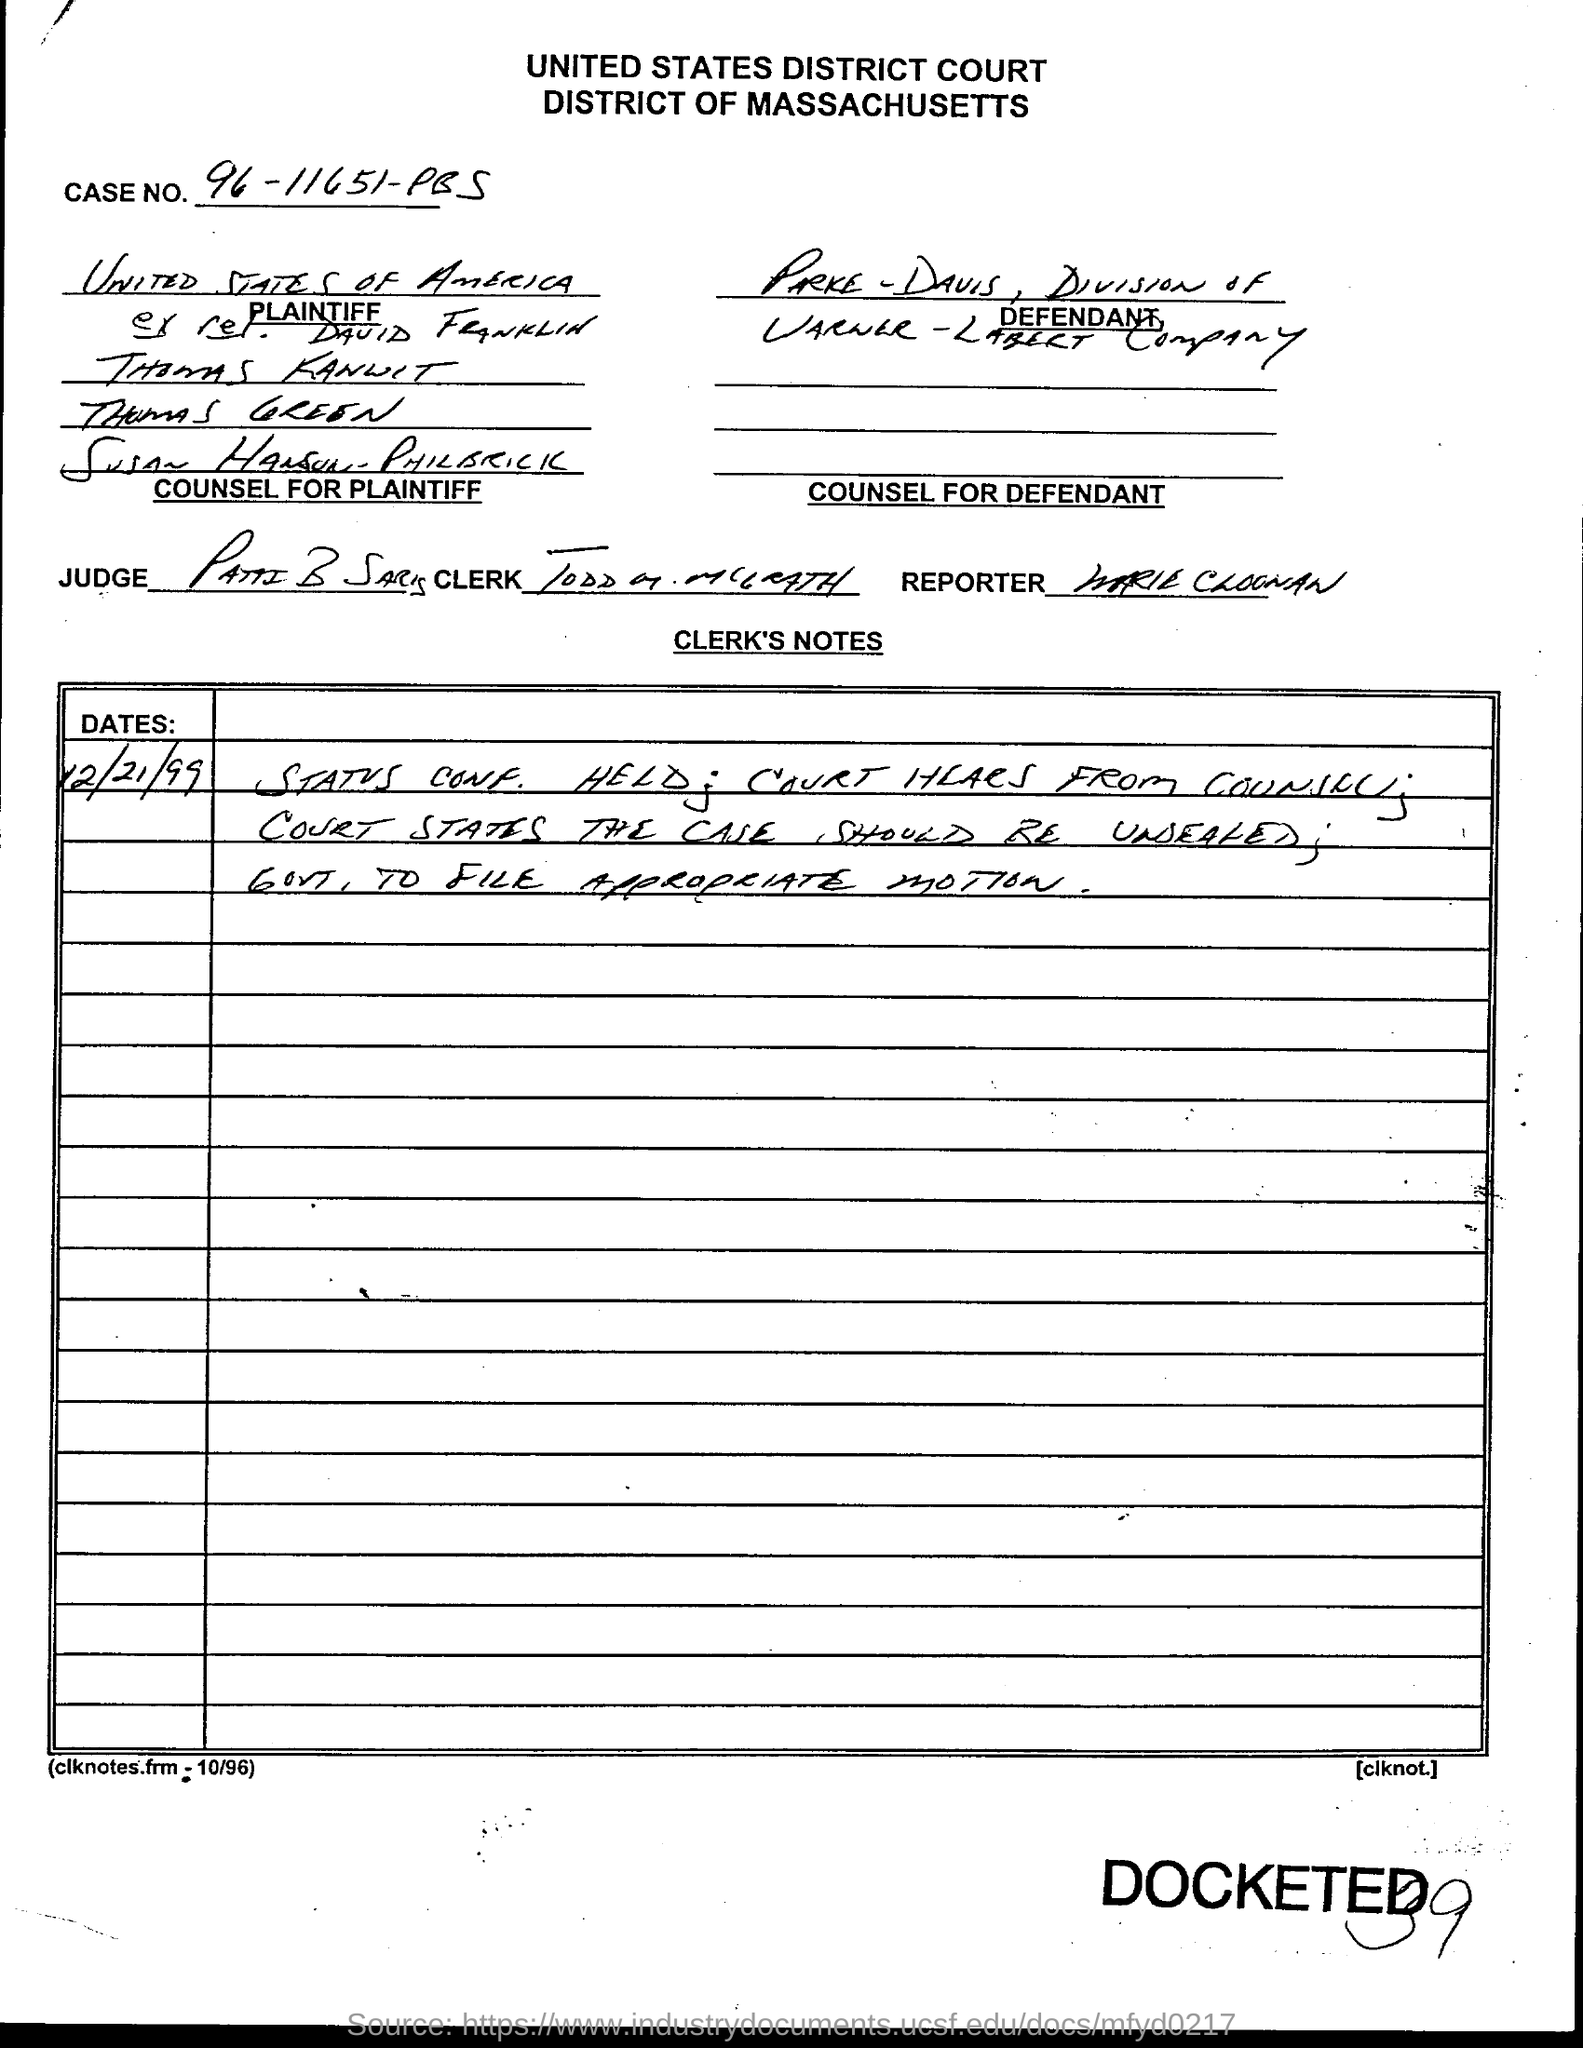What is the Case No.?
Offer a terse response. 96-11651-PBS. 